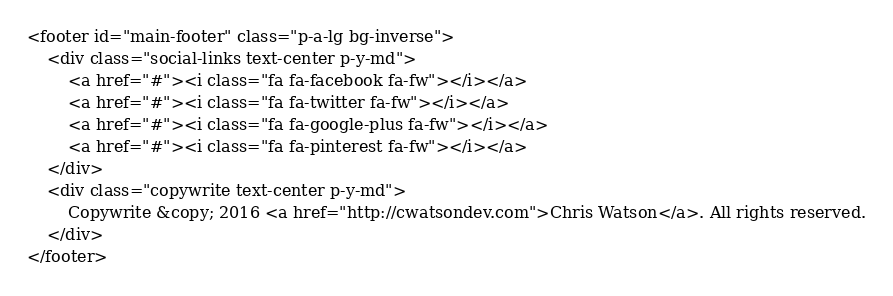Convert code to text. <code><loc_0><loc_0><loc_500><loc_500><_PHP_><footer id="main-footer" class="p-a-lg bg-inverse">
    <div class="social-links text-center p-y-md">
        <a href="#"><i class="fa fa-facebook fa-fw"></i></a>
        <a href="#"><i class="fa fa-twitter fa-fw"></i></a>
        <a href="#"><i class="fa fa-google-plus fa-fw"></i></a>
        <a href="#"><i class="fa fa-pinterest fa-fw"></i></a>
    </div>
    <div class="copywrite text-center p-y-md">
        Copywrite &copy; 2016 <a href="http://cwatsondev.com">Chris Watson</a>. All rights reserved.
    </div>
</footer></code> 